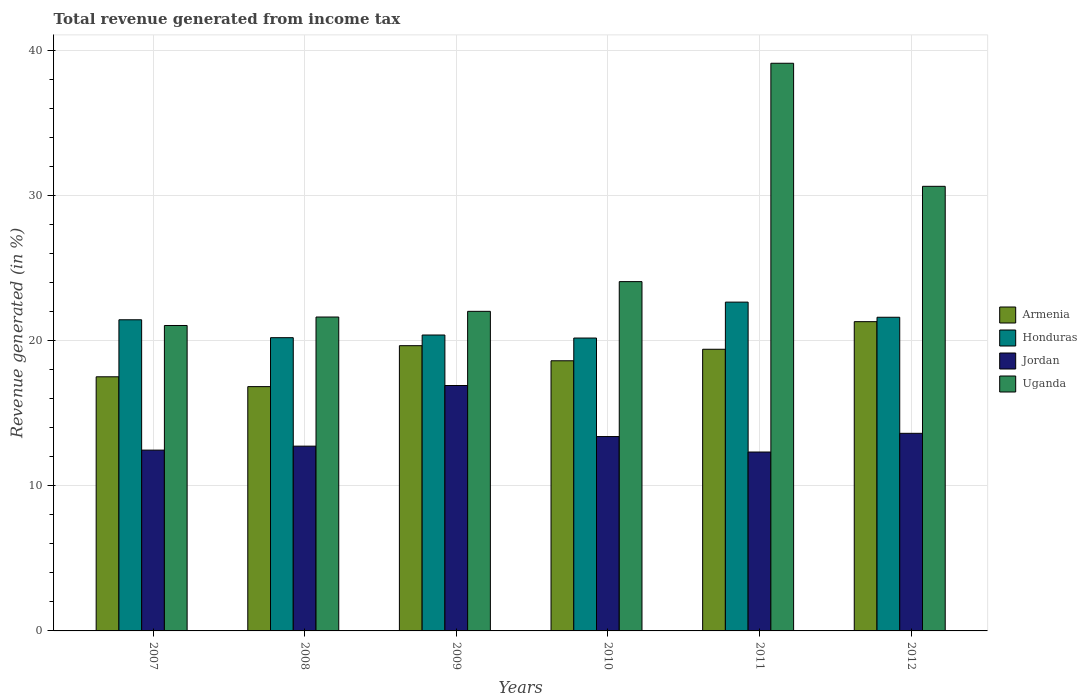How many different coloured bars are there?
Ensure brevity in your answer.  4. Are the number of bars per tick equal to the number of legend labels?
Provide a short and direct response. Yes. How many bars are there on the 6th tick from the left?
Keep it short and to the point. 4. How many bars are there on the 4th tick from the right?
Offer a very short reply. 4. What is the label of the 3rd group of bars from the left?
Offer a terse response. 2009. In how many cases, is the number of bars for a given year not equal to the number of legend labels?
Provide a succinct answer. 0. What is the total revenue generated in Armenia in 2011?
Your answer should be very brief. 19.41. Across all years, what is the maximum total revenue generated in Honduras?
Provide a succinct answer. 22.66. Across all years, what is the minimum total revenue generated in Jordan?
Make the answer very short. 12.33. In which year was the total revenue generated in Armenia minimum?
Ensure brevity in your answer.  2008. What is the total total revenue generated in Honduras in the graph?
Provide a succinct answer. 126.51. What is the difference between the total revenue generated in Armenia in 2007 and that in 2009?
Provide a short and direct response. -2.14. What is the difference between the total revenue generated in Uganda in 2010 and the total revenue generated in Honduras in 2012?
Your answer should be very brief. 2.46. What is the average total revenue generated in Honduras per year?
Your answer should be very brief. 21.09. In the year 2010, what is the difference between the total revenue generated in Honduras and total revenue generated in Armenia?
Provide a short and direct response. 1.57. In how many years, is the total revenue generated in Jordan greater than 38 %?
Ensure brevity in your answer.  0. What is the ratio of the total revenue generated in Honduras in 2007 to that in 2010?
Offer a terse response. 1.06. What is the difference between the highest and the second highest total revenue generated in Honduras?
Offer a very short reply. 1.04. What is the difference between the highest and the lowest total revenue generated in Honduras?
Offer a terse response. 2.48. In how many years, is the total revenue generated in Jordan greater than the average total revenue generated in Jordan taken over all years?
Provide a succinct answer. 2. What does the 2nd bar from the left in 2009 represents?
Your answer should be compact. Honduras. What does the 4th bar from the right in 2009 represents?
Your answer should be compact. Armenia. Is it the case that in every year, the sum of the total revenue generated in Armenia and total revenue generated in Honduras is greater than the total revenue generated in Jordan?
Make the answer very short. Yes. Are the values on the major ticks of Y-axis written in scientific E-notation?
Give a very brief answer. No. Where does the legend appear in the graph?
Provide a succinct answer. Center right. How are the legend labels stacked?
Give a very brief answer. Vertical. What is the title of the graph?
Provide a short and direct response. Total revenue generated from income tax. Does "Uruguay" appear as one of the legend labels in the graph?
Provide a succinct answer. No. What is the label or title of the X-axis?
Provide a short and direct response. Years. What is the label or title of the Y-axis?
Provide a short and direct response. Revenue generated (in %). What is the Revenue generated (in %) of Armenia in 2007?
Ensure brevity in your answer.  17.51. What is the Revenue generated (in %) in Honduras in 2007?
Provide a short and direct response. 21.44. What is the Revenue generated (in %) in Jordan in 2007?
Give a very brief answer. 12.46. What is the Revenue generated (in %) of Uganda in 2007?
Make the answer very short. 21.05. What is the Revenue generated (in %) of Armenia in 2008?
Provide a short and direct response. 16.84. What is the Revenue generated (in %) in Honduras in 2008?
Your answer should be very brief. 20.21. What is the Revenue generated (in %) of Jordan in 2008?
Make the answer very short. 12.73. What is the Revenue generated (in %) of Uganda in 2008?
Provide a short and direct response. 21.63. What is the Revenue generated (in %) of Armenia in 2009?
Your answer should be very brief. 19.66. What is the Revenue generated (in %) of Honduras in 2009?
Provide a succinct answer. 20.39. What is the Revenue generated (in %) of Jordan in 2009?
Your answer should be compact. 16.91. What is the Revenue generated (in %) of Uganda in 2009?
Make the answer very short. 22.03. What is the Revenue generated (in %) of Armenia in 2010?
Offer a very short reply. 18.62. What is the Revenue generated (in %) in Honduras in 2010?
Keep it short and to the point. 20.19. What is the Revenue generated (in %) of Jordan in 2010?
Your response must be concise. 13.4. What is the Revenue generated (in %) in Uganda in 2010?
Ensure brevity in your answer.  24.07. What is the Revenue generated (in %) in Armenia in 2011?
Your response must be concise. 19.41. What is the Revenue generated (in %) of Honduras in 2011?
Ensure brevity in your answer.  22.66. What is the Revenue generated (in %) of Jordan in 2011?
Your response must be concise. 12.33. What is the Revenue generated (in %) of Uganda in 2011?
Make the answer very short. 39.12. What is the Revenue generated (in %) of Armenia in 2012?
Your answer should be compact. 21.31. What is the Revenue generated (in %) of Honduras in 2012?
Your answer should be very brief. 21.62. What is the Revenue generated (in %) of Jordan in 2012?
Ensure brevity in your answer.  13.62. What is the Revenue generated (in %) of Uganda in 2012?
Provide a succinct answer. 30.64. Across all years, what is the maximum Revenue generated (in %) of Armenia?
Provide a succinct answer. 21.31. Across all years, what is the maximum Revenue generated (in %) in Honduras?
Keep it short and to the point. 22.66. Across all years, what is the maximum Revenue generated (in %) in Jordan?
Keep it short and to the point. 16.91. Across all years, what is the maximum Revenue generated (in %) in Uganda?
Ensure brevity in your answer.  39.12. Across all years, what is the minimum Revenue generated (in %) of Armenia?
Make the answer very short. 16.84. Across all years, what is the minimum Revenue generated (in %) in Honduras?
Keep it short and to the point. 20.19. Across all years, what is the minimum Revenue generated (in %) in Jordan?
Ensure brevity in your answer.  12.33. Across all years, what is the minimum Revenue generated (in %) in Uganda?
Provide a short and direct response. 21.05. What is the total Revenue generated (in %) in Armenia in the graph?
Offer a terse response. 113.36. What is the total Revenue generated (in %) of Honduras in the graph?
Provide a short and direct response. 126.51. What is the total Revenue generated (in %) of Jordan in the graph?
Offer a terse response. 81.45. What is the total Revenue generated (in %) in Uganda in the graph?
Your answer should be compact. 158.55. What is the difference between the Revenue generated (in %) of Armenia in 2007 and that in 2008?
Offer a terse response. 0.68. What is the difference between the Revenue generated (in %) of Honduras in 2007 and that in 2008?
Offer a very short reply. 1.23. What is the difference between the Revenue generated (in %) in Jordan in 2007 and that in 2008?
Your answer should be very brief. -0.27. What is the difference between the Revenue generated (in %) in Uganda in 2007 and that in 2008?
Make the answer very short. -0.58. What is the difference between the Revenue generated (in %) of Armenia in 2007 and that in 2009?
Make the answer very short. -2.14. What is the difference between the Revenue generated (in %) of Honduras in 2007 and that in 2009?
Provide a succinct answer. 1.05. What is the difference between the Revenue generated (in %) in Jordan in 2007 and that in 2009?
Offer a terse response. -4.45. What is the difference between the Revenue generated (in %) of Uganda in 2007 and that in 2009?
Give a very brief answer. -0.98. What is the difference between the Revenue generated (in %) of Armenia in 2007 and that in 2010?
Ensure brevity in your answer.  -1.1. What is the difference between the Revenue generated (in %) of Honduras in 2007 and that in 2010?
Give a very brief answer. 1.26. What is the difference between the Revenue generated (in %) in Jordan in 2007 and that in 2010?
Offer a terse response. -0.93. What is the difference between the Revenue generated (in %) in Uganda in 2007 and that in 2010?
Make the answer very short. -3.02. What is the difference between the Revenue generated (in %) in Armenia in 2007 and that in 2011?
Offer a very short reply. -1.9. What is the difference between the Revenue generated (in %) in Honduras in 2007 and that in 2011?
Make the answer very short. -1.22. What is the difference between the Revenue generated (in %) of Jordan in 2007 and that in 2011?
Offer a terse response. 0.13. What is the difference between the Revenue generated (in %) of Uganda in 2007 and that in 2011?
Provide a succinct answer. -18.07. What is the difference between the Revenue generated (in %) of Armenia in 2007 and that in 2012?
Your answer should be compact. -3.8. What is the difference between the Revenue generated (in %) of Honduras in 2007 and that in 2012?
Keep it short and to the point. -0.17. What is the difference between the Revenue generated (in %) of Jordan in 2007 and that in 2012?
Provide a short and direct response. -1.16. What is the difference between the Revenue generated (in %) in Uganda in 2007 and that in 2012?
Keep it short and to the point. -9.59. What is the difference between the Revenue generated (in %) of Armenia in 2008 and that in 2009?
Your answer should be very brief. -2.82. What is the difference between the Revenue generated (in %) in Honduras in 2008 and that in 2009?
Your answer should be very brief. -0.18. What is the difference between the Revenue generated (in %) in Jordan in 2008 and that in 2009?
Offer a terse response. -4.18. What is the difference between the Revenue generated (in %) in Uganda in 2008 and that in 2009?
Your answer should be compact. -0.39. What is the difference between the Revenue generated (in %) of Armenia in 2008 and that in 2010?
Provide a short and direct response. -1.78. What is the difference between the Revenue generated (in %) in Honduras in 2008 and that in 2010?
Ensure brevity in your answer.  0.02. What is the difference between the Revenue generated (in %) in Jordan in 2008 and that in 2010?
Give a very brief answer. -0.66. What is the difference between the Revenue generated (in %) in Uganda in 2008 and that in 2010?
Your answer should be very brief. -2.44. What is the difference between the Revenue generated (in %) in Armenia in 2008 and that in 2011?
Offer a terse response. -2.58. What is the difference between the Revenue generated (in %) of Honduras in 2008 and that in 2011?
Your answer should be very brief. -2.45. What is the difference between the Revenue generated (in %) in Jordan in 2008 and that in 2011?
Your response must be concise. 0.4. What is the difference between the Revenue generated (in %) of Uganda in 2008 and that in 2011?
Your answer should be compact. -17.49. What is the difference between the Revenue generated (in %) in Armenia in 2008 and that in 2012?
Your response must be concise. -4.48. What is the difference between the Revenue generated (in %) of Honduras in 2008 and that in 2012?
Offer a terse response. -1.41. What is the difference between the Revenue generated (in %) of Jordan in 2008 and that in 2012?
Make the answer very short. -0.88. What is the difference between the Revenue generated (in %) in Uganda in 2008 and that in 2012?
Ensure brevity in your answer.  -9.01. What is the difference between the Revenue generated (in %) in Armenia in 2009 and that in 2010?
Ensure brevity in your answer.  1.04. What is the difference between the Revenue generated (in %) in Honduras in 2009 and that in 2010?
Provide a succinct answer. 0.21. What is the difference between the Revenue generated (in %) of Jordan in 2009 and that in 2010?
Your answer should be compact. 3.52. What is the difference between the Revenue generated (in %) of Uganda in 2009 and that in 2010?
Offer a very short reply. -2.05. What is the difference between the Revenue generated (in %) of Armenia in 2009 and that in 2011?
Provide a short and direct response. 0.25. What is the difference between the Revenue generated (in %) of Honduras in 2009 and that in 2011?
Your answer should be compact. -2.27. What is the difference between the Revenue generated (in %) of Jordan in 2009 and that in 2011?
Your answer should be compact. 4.58. What is the difference between the Revenue generated (in %) of Uganda in 2009 and that in 2011?
Provide a succinct answer. -17.1. What is the difference between the Revenue generated (in %) in Armenia in 2009 and that in 2012?
Your answer should be compact. -1.66. What is the difference between the Revenue generated (in %) of Honduras in 2009 and that in 2012?
Keep it short and to the point. -1.22. What is the difference between the Revenue generated (in %) in Jordan in 2009 and that in 2012?
Give a very brief answer. 3.3. What is the difference between the Revenue generated (in %) of Uganda in 2009 and that in 2012?
Your answer should be very brief. -8.62. What is the difference between the Revenue generated (in %) of Armenia in 2010 and that in 2011?
Provide a succinct answer. -0.79. What is the difference between the Revenue generated (in %) in Honduras in 2010 and that in 2011?
Give a very brief answer. -2.48. What is the difference between the Revenue generated (in %) in Jordan in 2010 and that in 2011?
Offer a terse response. 1.07. What is the difference between the Revenue generated (in %) in Uganda in 2010 and that in 2011?
Provide a succinct answer. -15.05. What is the difference between the Revenue generated (in %) in Armenia in 2010 and that in 2012?
Your answer should be very brief. -2.7. What is the difference between the Revenue generated (in %) in Honduras in 2010 and that in 2012?
Give a very brief answer. -1.43. What is the difference between the Revenue generated (in %) of Jordan in 2010 and that in 2012?
Your response must be concise. -0.22. What is the difference between the Revenue generated (in %) of Uganda in 2010 and that in 2012?
Make the answer very short. -6.57. What is the difference between the Revenue generated (in %) in Armenia in 2011 and that in 2012?
Your response must be concise. -1.9. What is the difference between the Revenue generated (in %) in Honduras in 2011 and that in 2012?
Make the answer very short. 1.04. What is the difference between the Revenue generated (in %) in Jordan in 2011 and that in 2012?
Offer a terse response. -1.29. What is the difference between the Revenue generated (in %) in Uganda in 2011 and that in 2012?
Your response must be concise. 8.48. What is the difference between the Revenue generated (in %) in Armenia in 2007 and the Revenue generated (in %) in Honduras in 2008?
Provide a succinct answer. -2.7. What is the difference between the Revenue generated (in %) in Armenia in 2007 and the Revenue generated (in %) in Jordan in 2008?
Make the answer very short. 4.78. What is the difference between the Revenue generated (in %) of Armenia in 2007 and the Revenue generated (in %) of Uganda in 2008?
Offer a terse response. -4.12. What is the difference between the Revenue generated (in %) in Honduras in 2007 and the Revenue generated (in %) in Jordan in 2008?
Offer a very short reply. 8.71. What is the difference between the Revenue generated (in %) in Honduras in 2007 and the Revenue generated (in %) in Uganda in 2008?
Give a very brief answer. -0.19. What is the difference between the Revenue generated (in %) in Jordan in 2007 and the Revenue generated (in %) in Uganda in 2008?
Make the answer very short. -9.17. What is the difference between the Revenue generated (in %) of Armenia in 2007 and the Revenue generated (in %) of Honduras in 2009?
Offer a very short reply. -2.88. What is the difference between the Revenue generated (in %) in Armenia in 2007 and the Revenue generated (in %) in Jordan in 2009?
Offer a terse response. 0.6. What is the difference between the Revenue generated (in %) in Armenia in 2007 and the Revenue generated (in %) in Uganda in 2009?
Your response must be concise. -4.51. What is the difference between the Revenue generated (in %) of Honduras in 2007 and the Revenue generated (in %) of Jordan in 2009?
Your answer should be compact. 4.53. What is the difference between the Revenue generated (in %) in Honduras in 2007 and the Revenue generated (in %) in Uganda in 2009?
Keep it short and to the point. -0.58. What is the difference between the Revenue generated (in %) in Jordan in 2007 and the Revenue generated (in %) in Uganda in 2009?
Give a very brief answer. -9.56. What is the difference between the Revenue generated (in %) in Armenia in 2007 and the Revenue generated (in %) in Honduras in 2010?
Ensure brevity in your answer.  -2.67. What is the difference between the Revenue generated (in %) of Armenia in 2007 and the Revenue generated (in %) of Jordan in 2010?
Your answer should be compact. 4.12. What is the difference between the Revenue generated (in %) of Armenia in 2007 and the Revenue generated (in %) of Uganda in 2010?
Give a very brief answer. -6.56. What is the difference between the Revenue generated (in %) in Honduras in 2007 and the Revenue generated (in %) in Jordan in 2010?
Your answer should be compact. 8.05. What is the difference between the Revenue generated (in %) in Honduras in 2007 and the Revenue generated (in %) in Uganda in 2010?
Offer a terse response. -2.63. What is the difference between the Revenue generated (in %) of Jordan in 2007 and the Revenue generated (in %) of Uganda in 2010?
Ensure brevity in your answer.  -11.61. What is the difference between the Revenue generated (in %) in Armenia in 2007 and the Revenue generated (in %) in Honduras in 2011?
Give a very brief answer. -5.15. What is the difference between the Revenue generated (in %) of Armenia in 2007 and the Revenue generated (in %) of Jordan in 2011?
Offer a terse response. 5.19. What is the difference between the Revenue generated (in %) in Armenia in 2007 and the Revenue generated (in %) in Uganda in 2011?
Make the answer very short. -21.61. What is the difference between the Revenue generated (in %) of Honduras in 2007 and the Revenue generated (in %) of Jordan in 2011?
Offer a terse response. 9.12. What is the difference between the Revenue generated (in %) of Honduras in 2007 and the Revenue generated (in %) of Uganda in 2011?
Provide a succinct answer. -17.68. What is the difference between the Revenue generated (in %) in Jordan in 2007 and the Revenue generated (in %) in Uganda in 2011?
Provide a succinct answer. -26.66. What is the difference between the Revenue generated (in %) of Armenia in 2007 and the Revenue generated (in %) of Honduras in 2012?
Ensure brevity in your answer.  -4.1. What is the difference between the Revenue generated (in %) in Armenia in 2007 and the Revenue generated (in %) in Jordan in 2012?
Provide a succinct answer. 3.9. What is the difference between the Revenue generated (in %) of Armenia in 2007 and the Revenue generated (in %) of Uganda in 2012?
Ensure brevity in your answer.  -13.13. What is the difference between the Revenue generated (in %) in Honduras in 2007 and the Revenue generated (in %) in Jordan in 2012?
Give a very brief answer. 7.83. What is the difference between the Revenue generated (in %) in Honduras in 2007 and the Revenue generated (in %) in Uganda in 2012?
Your answer should be very brief. -9.2. What is the difference between the Revenue generated (in %) of Jordan in 2007 and the Revenue generated (in %) of Uganda in 2012?
Your answer should be compact. -18.18. What is the difference between the Revenue generated (in %) of Armenia in 2008 and the Revenue generated (in %) of Honduras in 2009?
Provide a short and direct response. -3.56. What is the difference between the Revenue generated (in %) in Armenia in 2008 and the Revenue generated (in %) in Jordan in 2009?
Your answer should be compact. -0.08. What is the difference between the Revenue generated (in %) in Armenia in 2008 and the Revenue generated (in %) in Uganda in 2009?
Your answer should be very brief. -5.19. What is the difference between the Revenue generated (in %) in Honduras in 2008 and the Revenue generated (in %) in Jordan in 2009?
Provide a short and direct response. 3.3. What is the difference between the Revenue generated (in %) of Honduras in 2008 and the Revenue generated (in %) of Uganda in 2009?
Your answer should be very brief. -1.82. What is the difference between the Revenue generated (in %) of Jordan in 2008 and the Revenue generated (in %) of Uganda in 2009?
Provide a succinct answer. -9.29. What is the difference between the Revenue generated (in %) in Armenia in 2008 and the Revenue generated (in %) in Honduras in 2010?
Ensure brevity in your answer.  -3.35. What is the difference between the Revenue generated (in %) in Armenia in 2008 and the Revenue generated (in %) in Jordan in 2010?
Your answer should be very brief. 3.44. What is the difference between the Revenue generated (in %) of Armenia in 2008 and the Revenue generated (in %) of Uganda in 2010?
Offer a very short reply. -7.24. What is the difference between the Revenue generated (in %) in Honduras in 2008 and the Revenue generated (in %) in Jordan in 2010?
Provide a succinct answer. 6.81. What is the difference between the Revenue generated (in %) in Honduras in 2008 and the Revenue generated (in %) in Uganda in 2010?
Give a very brief answer. -3.86. What is the difference between the Revenue generated (in %) of Jordan in 2008 and the Revenue generated (in %) of Uganda in 2010?
Offer a terse response. -11.34. What is the difference between the Revenue generated (in %) in Armenia in 2008 and the Revenue generated (in %) in Honduras in 2011?
Offer a very short reply. -5.82. What is the difference between the Revenue generated (in %) in Armenia in 2008 and the Revenue generated (in %) in Jordan in 2011?
Provide a short and direct response. 4.51. What is the difference between the Revenue generated (in %) in Armenia in 2008 and the Revenue generated (in %) in Uganda in 2011?
Your response must be concise. -22.29. What is the difference between the Revenue generated (in %) in Honduras in 2008 and the Revenue generated (in %) in Jordan in 2011?
Offer a very short reply. 7.88. What is the difference between the Revenue generated (in %) in Honduras in 2008 and the Revenue generated (in %) in Uganda in 2011?
Your response must be concise. -18.91. What is the difference between the Revenue generated (in %) of Jordan in 2008 and the Revenue generated (in %) of Uganda in 2011?
Give a very brief answer. -26.39. What is the difference between the Revenue generated (in %) of Armenia in 2008 and the Revenue generated (in %) of Honduras in 2012?
Provide a succinct answer. -4.78. What is the difference between the Revenue generated (in %) in Armenia in 2008 and the Revenue generated (in %) in Jordan in 2012?
Make the answer very short. 3.22. What is the difference between the Revenue generated (in %) in Armenia in 2008 and the Revenue generated (in %) in Uganda in 2012?
Provide a short and direct response. -13.8. What is the difference between the Revenue generated (in %) in Honduras in 2008 and the Revenue generated (in %) in Jordan in 2012?
Provide a succinct answer. 6.59. What is the difference between the Revenue generated (in %) in Honduras in 2008 and the Revenue generated (in %) in Uganda in 2012?
Your answer should be compact. -10.43. What is the difference between the Revenue generated (in %) of Jordan in 2008 and the Revenue generated (in %) of Uganda in 2012?
Ensure brevity in your answer.  -17.91. What is the difference between the Revenue generated (in %) in Armenia in 2009 and the Revenue generated (in %) in Honduras in 2010?
Provide a succinct answer. -0.53. What is the difference between the Revenue generated (in %) in Armenia in 2009 and the Revenue generated (in %) in Jordan in 2010?
Keep it short and to the point. 6.26. What is the difference between the Revenue generated (in %) of Armenia in 2009 and the Revenue generated (in %) of Uganda in 2010?
Give a very brief answer. -4.42. What is the difference between the Revenue generated (in %) in Honduras in 2009 and the Revenue generated (in %) in Jordan in 2010?
Make the answer very short. 7. What is the difference between the Revenue generated (in %) in Honduras in 2009 and the Revenue generated (in %) in Uganda in 2010?
Provide a succinct answer. -3.68. What is the difference between the Revenue generated (in %) of Jordan in 2009 and the Revenue generated (in %) of Uganda in 2010?
Provide a short and direct response. -7.16. What is the difference between the Revenue generated (in %) of Armenia in 2009 and the Revenue generated (in %) of Honduras in 2011?
Make the answer very short. -3. What is the difference between the Revenue generated (in %) of Armenia in 2009 and the Revenue generated (in %) of Jordan in 2011?
Give a very brief answer. 7.33. What is the difference between the Revenue generated (in %) of Armenia in 2009 and the Revenue generated (in %) of Uganda in 2011?
Provide a succinct answer. -19.46. What is the difference between the Revenue generated (in %) of Honduras in 2009 and the Revenue generated (in %) of Jordan in 2011?
Your answer should be compact. 8.06. What is the difference between the Revenue generated (in %) of Honduras in 2009 and the Revenue generated (in %) of Uganda in 2011?
Provide a short and direct response. -18.73. What is the difference between the Revenue generated (in %) in Jordan in 2009 and the Revenue generated (in %) in Uganda in 2011?
Ensure brevity in your answer.  -22.21. What is the difference between the Revenue generated (in %) in Armenia in 2009 and the Revenue generated (in %) in Honduras in 2012?
Make the answer very short. -1.96. What is the difference between the Revenue generated (in %) in Armenia in 2009 and the Revenue generated (in %) in Jordan in 2012?
Provide a short and direct response. 6.04. What is the difference between the Revenue generated (in %) of Armenia in 2009 and the Revenue generated (in %) of Uganda in 2012?
Give a very brief answer. -10.98. What is the difference between the Revenue generated (in %) of Honduras in 2009 and the Revenue generated (in %) of Jordan in 2012?
Keep it short and to the point. 6.78. What is the difference between the Revenue generated (in %) of Honduras in 2009 and the Revenue generated (in %) of Uganda in 2012?
Provide a short and direct response. -10.25. What is the difference between the Revenue generated (in %) in Jordan in 2009 and the Revenue generated (in %) in Uganda in 2012?
Provide a short and direct response. -13.73. What is the difference between the Revenue generated (in %) in Armenia in 2010 and the Revenue generated (in %) in Honduras in 2011?
Your answer should be very brief. -4.04. What is the difference between the Revenue generated (in %) in Armenia in 2010 and the Revenue generated (in %) in Jordan in 2011?
Provide a short and direct response. 6.29. What is the difference between the Revenue generated (in %) of Armenia in 2010 and the Revenue generated (in %) of Uganda in 2011?
Give a very brief answer. -20.5. What is the difference between the Revenue generated (in %) of Honduras in 2010 and the Revenue generated (in %) of Jordan in 2011?
Provide a succinct answer. 7.86. What is the difference between the Revenue generated (in %) in Honduras in 2010 and the Revenue generated (in %) in Uganda in 2011?
Give a very brief answer. -18.94. What is the difference between the Revenue generated (in %) in Jordan in 2010 and the Revenue generated (in %) in Uganda in 2011?
Provide a short and direct response. -25.73. What is the difference between the Revenue generated (in %) in Armenia in 2010 and the Revenue generated (in %) in Honduras in 2012?
Your response must be concise. -3. What is the difference between the Revenue generated (in %) in Armenia in 2010 and the Revenue generated (in %) in Jordan in 2012?
Your response must be concise. 5. What is the difference between the Revenue generated (in %) in Armenia in 2010 and the Revenue generated (in %) in Uganda in 2012?
Offer a terse response. -12.02. What is the difference between the Revenue generated (in %) in Honduras in 2010 and the Revenue generated (in %) in Jordan in 2012?
Your answer should be very brief. 6.57. What is the difference between the Revenue generated (in %) in Honduras in 2010 and the Revenue generated (in %) in Uganda in 2012?
Give a very brief answer. -10.46. What is the difference between the Revenue generated (in %) of Jordan in 2010 and the Revenue generated (in %) of Uganda in 2012?
Your response must be concise. -17.25. What is the difference between the Revenue generated (in %) of Armenia in 2011 and the Revenue generated (in %) of Honduras in 2012?
Offer a terse response. -2.21. What is the difference between the Revenue generated (in %) of Armenia in 2011 and the Revenue generated (in %) of Jordan in 2012?
Your answer should be very brief. 5.79. What is the difference between the Revenue generated (in %) of Armenia in 2011 and the Revenue generated (in %) of Uganda in 2012?
Offer a terse response. -11.23. What is the difference between the Revenue generated (in %) of Honduras in 2011 and the Revenue generated (in %) of Jordan in 2012?
Your response must be concise. 9.04. What is the difference between the Revenue generated (in %) of Honduras in 2011 and the Revenue generated (in %) of Uganda in 2012?
Keep it short and to the point. -7.98. What is the difference between the Revenue generated (in %) of Jordan in 2011 and the Revenue generated (in %) of Uganda in 2012?
Keep it short and to the point. -18.31. What is the average Revenue generated (in %) of Armenia per year?
Make the answer very short. 18.89. What is the average Revenue generated (in %) of Honduras per year?
Make the answer very short. 21.09. What is the average Revenue generated (in %) in Jordan per year?
Give a very brief answer. 13.58. What is the average Revenue generated (in %) of Uganda per year?
Ensure brevity in your answer.  26.42. In the year 2007, what is the difference between the Revenue generated (in %) of Armenia and Revenue generated (in %) of Honduras?
Keep it short and to the point. -3.93. In the year 2007, what is the difference between the Revenue generated (in %) of Armenia and Revenue generated (in %) of Jordan?
Provide a short and direct response. 5.05. In the year 2007, what is the difference between the Revenue generated (in %) in Armenia and Revenue generated (in %) in Uganda?
Your answer should be very brief. -3.54. In the year 2007, what is the difference between the Revenue generated (in %) in Honduras and Revenue generated (in %) in Jordan?
Provide a succinct answer. 8.98. In the year 2007, what is the difference between the Revenue generated (in %) of Honduras and Revenue generated (in %) of Uganda?
Make the answer very short. 0.39. In the year 2007, what is the difference between the Revenue generated (in %) of Jordan and Revenue generated (in %) of Uganda?
Provide a succinct answer. -8.59. In the year 2008, what is the difference between the Revenue generated (in %) of Armenia and Revenue generated (in %) of Honduras?
Ensure brevity in your answer.  -3.37. In the year 2008, what is the difference between the Revenue generated (in %) in Armenia and Revenue generated (in %) in Jordan?
Your response must be concise. 4.1. In the year 2008, what is the difference between the Revenue generated (in %) of Armenia and Revenue generated (in %) of Uganda?
Make the answer very short. -4.8. In the year 2008, what is the difference between the Revenue generated (in %) in Honduras and Revenue generated (in %) in Jordan?
Give a very brief answer. 7.48. In the year 2008, what is the difference between the Revenue generated (in %) in Honduras and Revenue generated (in %) in Uganda?
Give a very brief answer. -1.42. In the year 2008, what is the difference between the Revenue generated (in %) in Jordan and Revenue generated (in %) in Uganda?
Your answer should be compact. -8.9. In the year 2009, what is the difference between the Revenue generated (in %) in Armenia and Revenue generated (in %) in Honduras?
Your answer should be very brief. -0.74. In the year 2009, what is the difference between the Revenue generated (in %) in Armenia and Revenue generated (in %) in Jordan?
Ensure brevity in your answer.  2.74. In the year 2009, what is the difference between the Revenue generated (in %) of Armenia and Revenue generated (in %) of Uganda?
Provide a succinct answer. -2.37. In the year 2009, what is the difference between the Revenue generated (in %) of Honduras and Revenue generated (in %) of Jordan?
Ensure brevity in your answer.  3.48. In the year 2009, what is the difference between the Revenue generated (in %) in Honduras and Revenue generated (in %) in Uganda?
Provide a succinct answer. -1.63. In the year 2009, what is the difference between the Revenue generated (in %) of Jordan and Revenue generated (in %) of Uganda?
Your answer should be very brief. -5.11. In the year 2010, what is the difference between the Revenue generated (in %) of Armenia and Revenue generated (in %) of Honduras?
Your response must be concise. -1.57. In the year 2010, what is the difference between the Revenue generated (in %) in Armenia and Revenue generated (in %) in Jordan?
Provide a short and direct response. 5.22. In the year 2010, what is the difference between the Revenue generated (in %) of Armenia and Revenue generated (in %) of Uganda?
Offer a terse response. -5.45. In the year 2010, what is the difference between the Revenue generated (in %) of Honduras and Revenue generated (in %) of Jordan?
Keep it short and to the point. 6.79. In the year 2010, what is the difference between the Revenue generated (in %) in Honduras and Revenue generated (in %) in Uganda?
Provide a succinct answer. -3.89. In the year 2010, what is the difference between the Revenue generated (in %) of Jordan and Revenue generated (in %) of Uganda?
Your answer should be compact. -10.68. In the year 2011, what is the difference between the Revenue generated (in %) in Armenia and Revenue generated (in %) in Honduras?
Your response must be concise. -3.25. In the year 2011, what is the difference between the Revenue generated (in %) in Armenia and Revenue generated (in %) in Jordan?
Make the answer very short. 7.08. In the year 2011, what is the difference between the Revenue generated (in %) of Armenia and Revenue generated (in %) of Uganda?
Offer a terse response. -19.71. In the year 2011, what is the difference between the Revenue generated (in %) of Honduras and Revenue generated (in %) of Jordan?
Your answer should be compact. 10.33. In the year 2011, what is the difference between the Revenue generated (in %) in Honduras and Revenue generated (in %) in Uganda?
Your answer should be very brief. -16.46. In the year 2011, what is the difference between the Revenue generated (in %) in Jordan and Revenue generated (in %) in Uganda?
Keep it short and to the point. -26.79. In the year 2012, what is the difference between the Revenue generated (in %) in Armenia and Revenue generated (in %) in Honduras?
Provide a succinct answer. -0.3. In the year 2012, what is the difference between the Revenue generated (in %) in Armenia and Revenue generated (in %) in Jordan?
Your answer should be very brief. 7.7. In the year 2012, what is the difference between the Revenue generated (in %) of Armenia and Revenue generated (in %) of Uganda?
Offer a terse response. -9.33. In the year 2012, what is the difference between the Revenue generated (in %) in Honduras and Revenue generated (in %) in Jordan?
Offer a very short reply. 8. In the year 2012, what is the difference between the Revenue generated (in %) in Honduras and Revenue generated (in %) in Uganda?
Your answer should be compact. -9.02. In the year 2012, what is the difference between the Revenue generated (in %) in Jordan and Revenue generated (in %) in Uganda?
Offer a terse response. -17.02. What is the ratio of the Revenue generated (in %) in Armenia in 2007 to that in 2008?
Provide a succinct answer. 1.04. What is the ratio of the Revenue generated (in %) in Honduras in 2007 to that in 2008?
Your answer should be compact. 1.06. What is the ratio of the Revenue generated (in %) in Jordan in 2007 to that in 2008?
Give a very brief answer. 0.98. What is the ratio of the Revenue generated (in %) of Armenia in 2007 to that in 2009?
Offer a very short reply. 0.89. What is the ratio of the Revenue generated (in %) of Honduras in 2007 to that in 2009?
Your answer should be very brief. 1.05. What is the ratio of the Revenue generated (in %) of Jordan in 2007 to that in 2009?
Make the answer very short. 0.74. What is the ratio of the Revenue generated (in %) in Uganda in 2007 to that in 2009?
Provide a short and direct response. 0.96. What is the ratio of the Revenue generated (in %) in Armenia in 2007 to that in 2010?
Your answer should be compact. 0.94. What is the ratio of the Revenue generated (in %) of Honduras in 2007 to that in 2010?
Your answer should be compact. 1.06. What is the ratio of the Revenue generated (in %) of Jordan in 2007 to that in 2010?
Your answer should be very brief. 0.93. What is the ratio of the Revenue generated (in %) of Uganda in 2007 to that in 2010?
Your response must be concise. 0.87. What is the ratio of the Revenue generated (in %) in Armenia in 2007 to that in 2011?
Give a very brief answer. 0.9. What is the ratio of the Revenue generated (in %) of Honduras in 2007 to that in 2011?
Offer a very short reply. 0.95. What is the ratio of the Revenue generated (in %) of Jordan in 2007 to that in 2011?
Make the answer very short. 1.01. What is the ratio of the Revenue generated (in %) in Uganda in 2007 to that in 2011?
Keep it short and to the point. 0.54. What is the ratio of the Revenue generated (in %) of Armenia in 2007 to that in 2012?
Ensure brevity in your answer.  0.82. What is the ratio of the Revenue generated (in %) of Jordan in 2007 to that in 2012?
Make the answer very short. 0.92. What is the ratio of the Revenue generated (in %) in Uganda in 2007 to that in 2012?
Make the answer very short. 0.69. What is the ratio of the Revenue generated (in %) of Armenia in 2008 to that in 2009?
Make the answer very short. 0.86. What is the ratio of the Revenue generated (in %) in Honduras in 2008 to that in 2009?
Your response must be concise. 0.99. What is the ratio of the Revenue generated (in %) in Jordan in 2008 to that in 2009?
Keep it short and to the point. 0.75. What is the ratio of the Revenue generated (in %) in Uganda in 2008 to that in 2009?
Your answer should be very brief. 0.98. What is the ratio of the Revenue generated (in %) of Armenia in 2008 to that in 2010?
Give a very brief answer. 0.9. What is the ratio of the Revenue generated (in %) in Honduras in 2008 to that in 2010?
Your answer should be very brief. 1. What is the ratio of the Revenue generated (in %) in Jordan in 2008 to that in 2010?
Offer a terse response. 0.95. What is the ratio of the Revenue generated (in %) of Uganda in 2008 to that in 2010?
Offer a very short reply. 0.9. What is the ratio of the Revenue generated (in %) in Armenia in 2008 to that in 2011?
Offer a very short reply. 0.87. What is the ratio of the Revenue generated (in %) in Honduras in 2008 to that in 2011?
Ensure brevity in your answer.  0.89. What is the ratio of the Revenue generated (in %) in Jordan in 2008 to that in 2011?
Offer a very short reply. 1.03. What is the ratio of the Revenue generated (in %) in Uganda in 2008 to that in 2011?
Offer a very short reply. 0.55. What is the ratio of the Revenue generated (in %) in Armenia in 2008 to that in 2012?
Provide a short and direct response. 0.79. What is the ratio of the Revenue generated (in %) of Honduras in 2008 to that in 2012?
Your answer should be very brief. 0.93. What is the ratio of the Revenue generated (in %) in Jordan in 2008 to that in 2012?
Your answer should be very brief. 0.94. What is the ratio of the Revenue generated (in %) in Uganda in 2008 to that in 2012?
Your response must be concise. 0.71. What is the ratio of the Revenue generated (in %) of Armenia in 2009 to that in 2010?
Offer a very short reply. 1.06. What is the ratio of the Revenue generated (in %) of Honduras in 2009 to that in 2010?
Keep it short and to the point. 1.01. What is the ratio of the Revenue generated (in %) of Jordan in 2009 to that in 2010?
Keep it short and to the point. 1.26. What is the ratio of the Revenue generated (in %) in Uganda in 2009 to that in 2010?
Provide a succinct answer. 0.91. What is the ratio of the Revenue generated (in %) of Armenia in 2009 to that in 2011?
Make the answer very short. 1.01. What is the ratio of the Revenue generated (in %) in Jordan in 2009 to that in 2011?
Your answer should be compact. 1.37. What is the ratio of the Revenue generated (in %) in Uganda in 2009 to that in 2011?
Provide a short and direct response. 0.56. What is the ratio of the Revenue generated (in %) of Armenia in 2009 to that in 2012?
Provide a succinct answer. 0.92. What is the ratio of the Revenue generated (in %) in Honduras in 2009 to that in 2012?
Ensure brevity in your answer.  0.94. What is the ratio of the Revenue generated (in %) in Jordan in 2009 to that in 2012?
Provide a short and direct response. 1.24. What is the ratio of the Revenue generated (in %) of Uganda in 2009 to that in 2012?
Your response must be concise. 0.72. What is the ratio of the Revenue generated (in %) in Armenia in 2010 to that in 2011?
Keep it short and to the point. 0.96. What is the ratio of the Revenue generated (in %) in Honduras in 2010 to that in 2011?
Provide a short and direct response. 0.89. What is the ratio of the Revenue generated (in %) in Jordan in 2010 to that in 2011?
Provide a short and direct response. 1.09. What is the ratio of the Revenue generated (in %) of Uganda in 2010 to that in 2011?
Keep it short and to the point. 0.62. What is the ratio of the Revenue generated (in %) in Armenia in 2010 to that in 2012?
Give a very brief answer. 0.87. What is the ratio of the Revenue generated (in %) of Honduras in 2010 to that in 2012?
Your answer should be compact. 0.93. What is the ratio of the Revenue generated (in %) in Jordan in 2010 to that in 2012?
Offer a very short reply. 0.98. What is the ratio of the Revenue generated (in %) of Uganda in 2010 to that in 2012?
Keep it short and to the point. 0.79. What is the ratio of the Revenue generated (in %) in Armenia in 2011 to that in 2012?
Provide a short and direct response. 0.91. What is the ratio of the Revenue generated (in %) in Honduras in 2011 to that in 2012?
Your answer should be compact. 1.05. What is the ratio of the Revenue generated (in %) in Jordan in 2011 to that in 2012?
Keep it short and to the point. 0.91. What is the ratio of the Revenue generated (in %) of Uganda in 2011 to that in 2012?
Provide a short and direct response. 1.28. What is the difference between the highest and the second highest Revenue generated (in %) of Armenia?
Offer a terse response. 1.66. What is the difference between the highest and the second highest Revenue generated (in %) of Honduras?
Your answer should be very brief. 1.04. What is the difference between the highest and the second highest Revenue generated (in %) in Jordan?
Your response must be concise. 3.3. What is the difference between the highest and the second highest Revenue generated (in %) of Uganda?
Your response must be concise. 8.48. What is the difference between the highest and the lowest Revenue generated (in %) in Armenia?
Your answer should be compact. 4.48. What is the difference between the highest and the lowest Revenue generated (in %) of Honduras?
Keep it short and to the point. 2.48. What is the difference between the highest and the lowest Revenue generated (in %) of Jordan?
Your answer should be very brief. 4.58. What is the difference between the highest and the lowest Revenue generated (in %) in Uganda?
Your answer should be compact. 18.07. 